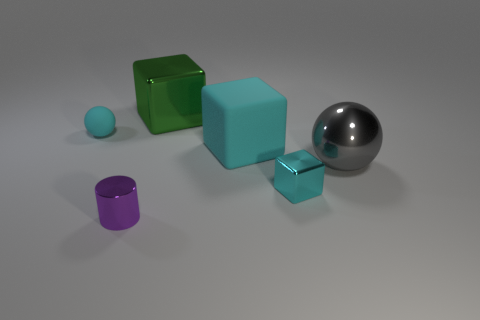Is the size of the object that is to the right of the small block the same as the matte thing that is in front of the cyan matte sphere?
Your response must be concise. Yes. How many other objects are the same material as the big cyan cube?
Give a very brief answer. 1. How many rubber things are tiny gray things or cyan objects?
Your answer should be very brief. 2. Is the number of tiny purple objects less than the number of small cyan cylinders?
Give a very brief answer. No. There is a cyan metal cube; is its size the same as the gray ball in front of the large cyan thing?
Give a very brief answer. No. Is there anything else that is the same shape as the tiny purple object?
Your answer should be very brief. No. How big is the green block?
Give a very brief answer. Large. Is the number of gray spheres that are behind the green block less than the number of rubber spheres?
Your response must be concise. Yes. Do the green block and the purple metallic cylinder have the same size?
Provide a short and direct response. No. There is another thing that is made of the same material as the big cyan object; what is its color?
Offer a very short reply. Cyan. 